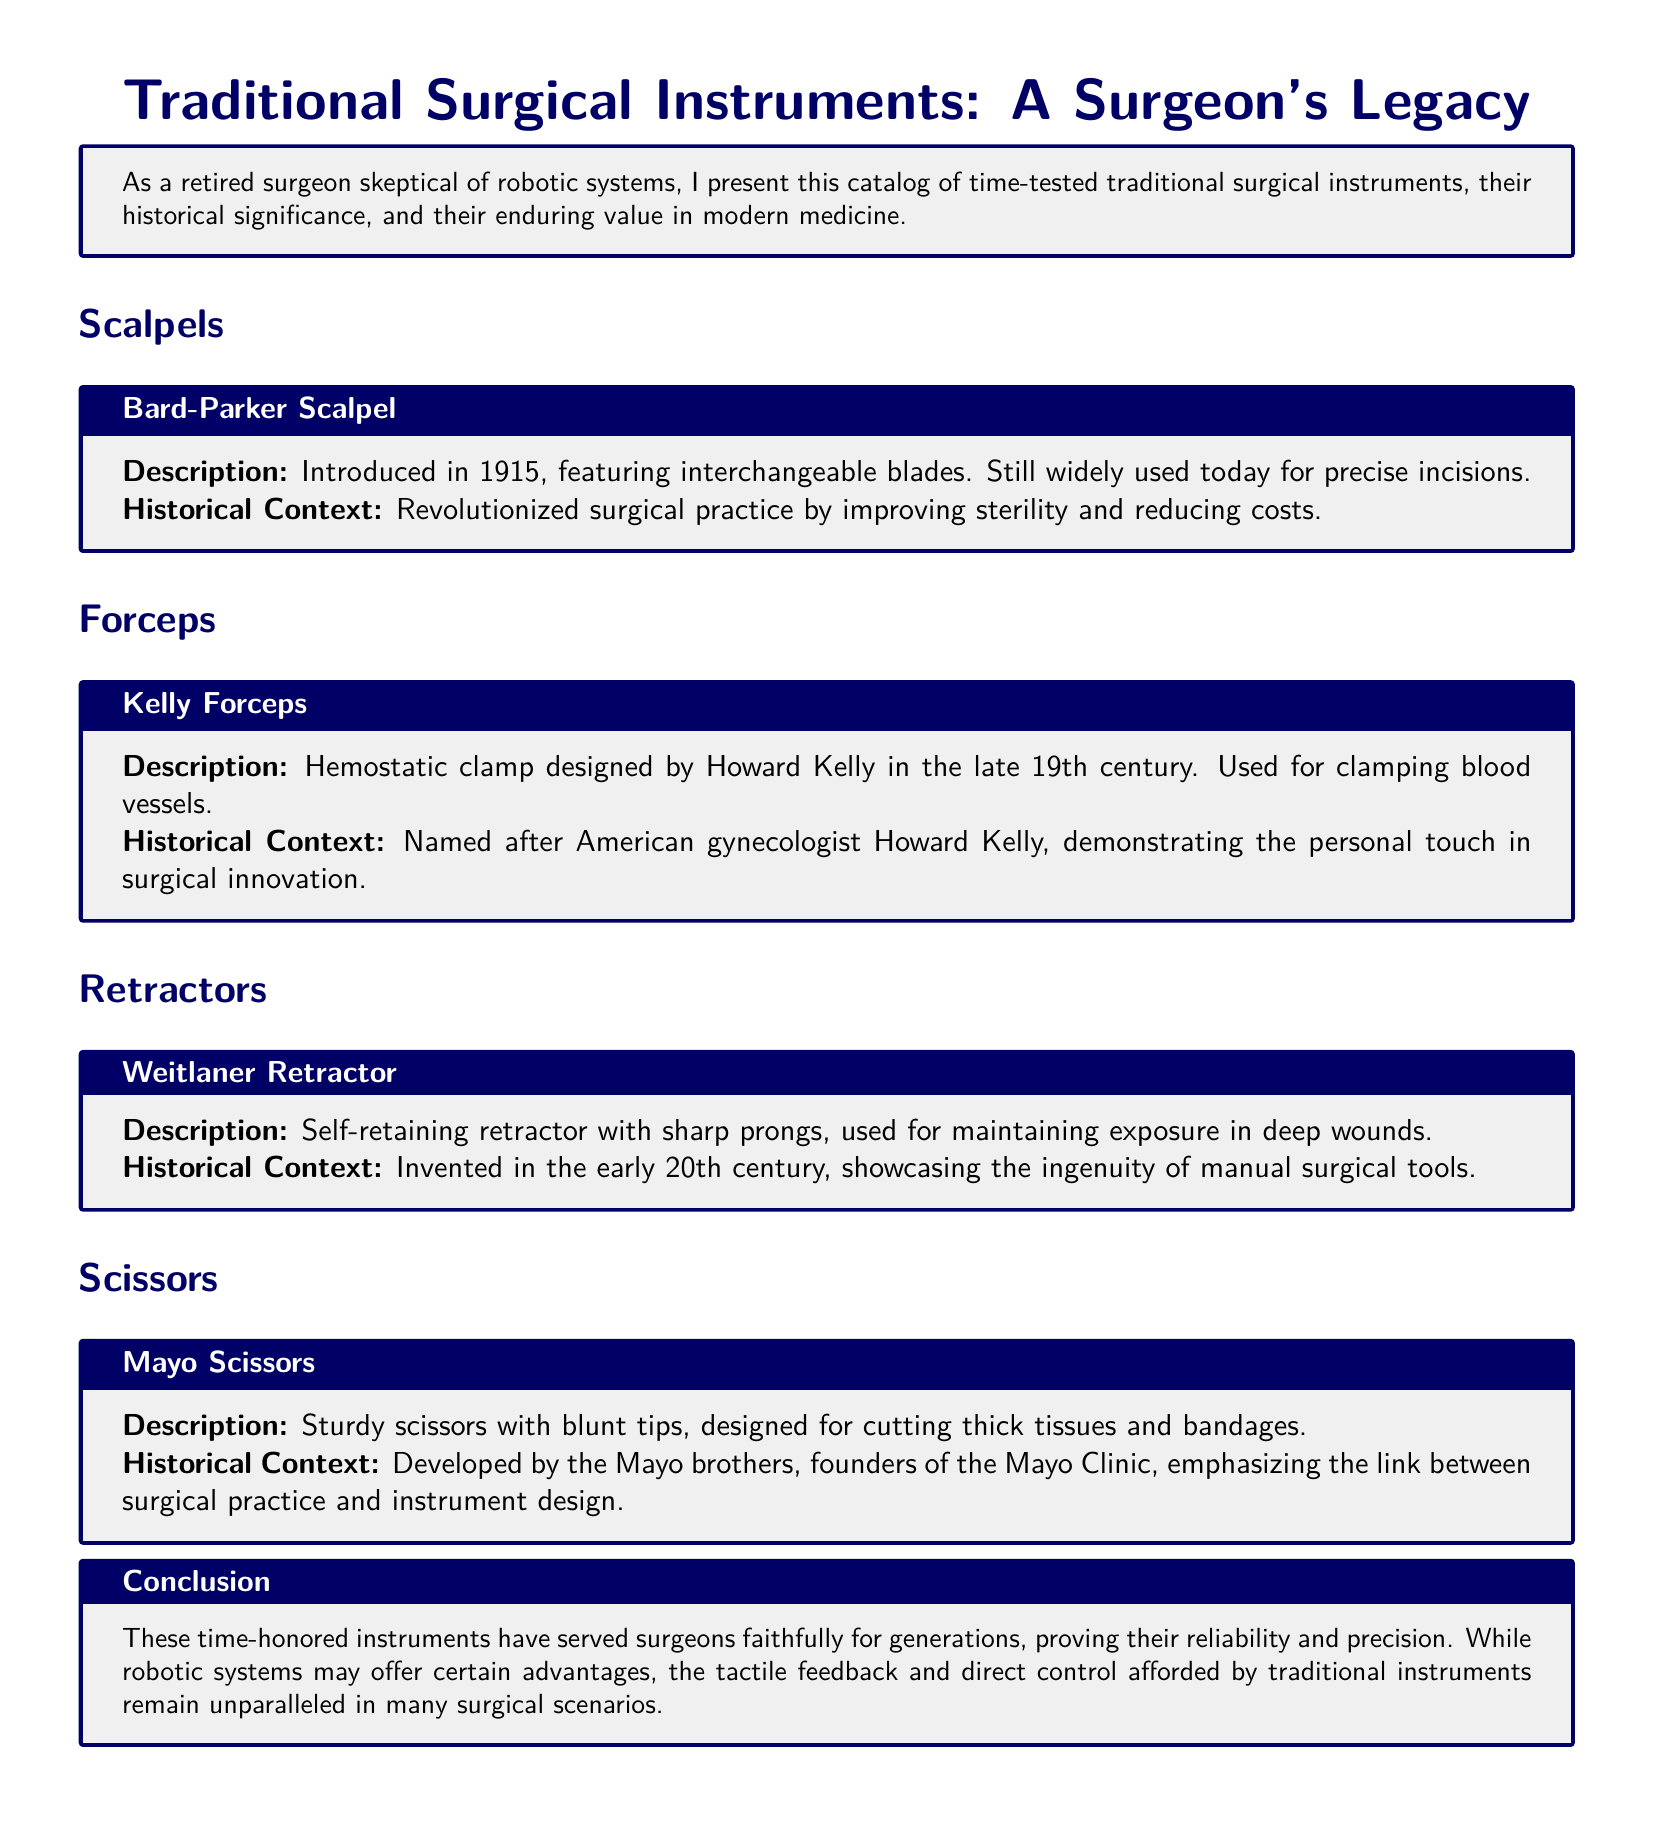What year was the Bard-Parker Scalpel introduced? The Bard-Parker Scalpel was introduced in 1915, as noted in the description.
Answer: 1915 Who designed the Kelly Forceps? The Kelly Forceps were designed by Howard Kelly, which is mentioned in the historical context.
Answer: Howard Kelly What type of retractor is the Weitlaner? The Weitlaner is a self-retaining retractor, explicitly stated in the document.
Answer: Self-retaining retractor Which surgical instruments are highlighted in the catalog? The document highlights scalpels, forceps, retractors, and scissors, as outlined in the sections.
Answer: Scalpels, forceps, retractors, scissors What is the historical significance of the Mayo Scissors? The Mayo Scissors were developed by the Mayo brothers, linking them to the history of the Mayo Clinic.
Answer: Mayo brothers What feature distinguishes the Bard-Parker Scalpel? The Bard-Parker Scalpel features interchangeable blades, as described in its section.
Answer: Interchangeable blades When were the concepts behind the Weitlaner Retractor introduced? The Weitlaner Retractor was invented in the early 20th century, indicated in the historical context.
Answer: Early 20th century What is the main benefit of traditional instruments according to the conclusion? The conclusion states that traditional instruments provide tactile feedback and direct control, highlighting their advantages.
Answer: Tactile feedback and direct control 